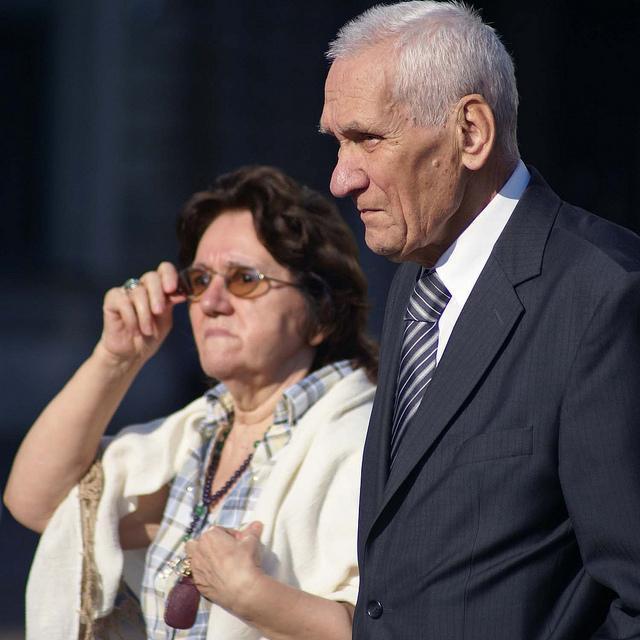Why are her glasses that color?
Select the accurate response from the four choices given to answer the question.
Options: Paint, sunlight, prescription, style. Sunlight. 